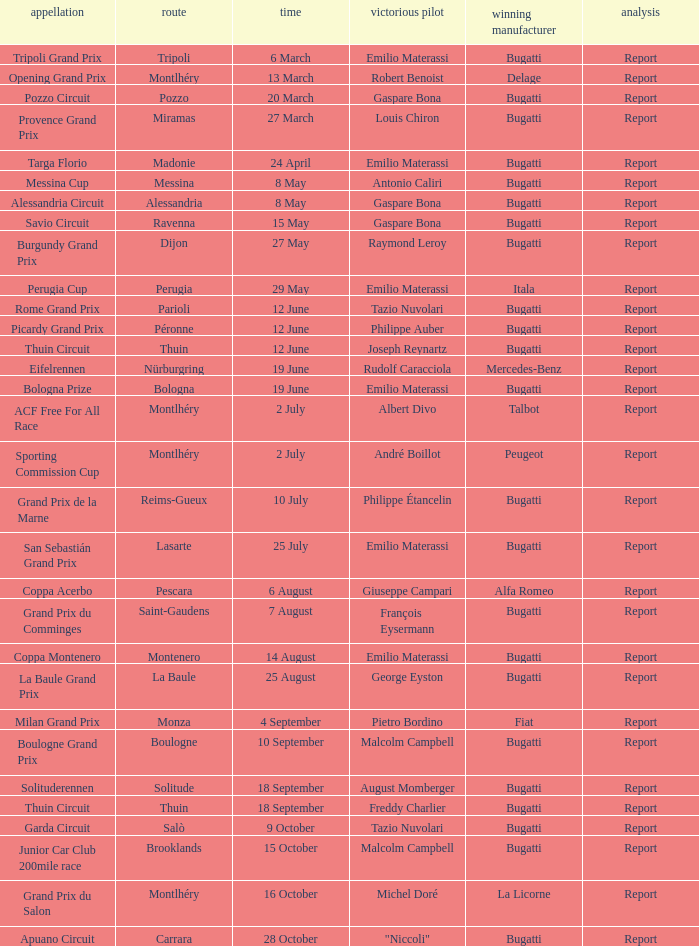When did Gaspare Bona win the Pozzo Circuit? 20 March. 